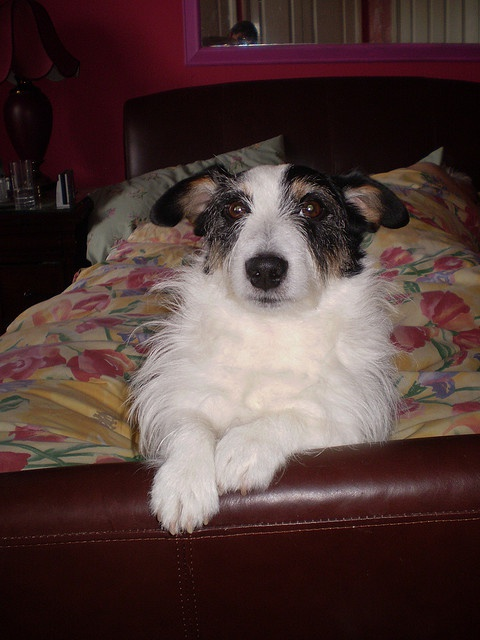Describe the objects in this image and their specific colors. I can see bed in black, gray, maroon, and lightgray tones, dog in black, lightgray, and darkgray tones, and cup in black and gray tones in this image. 